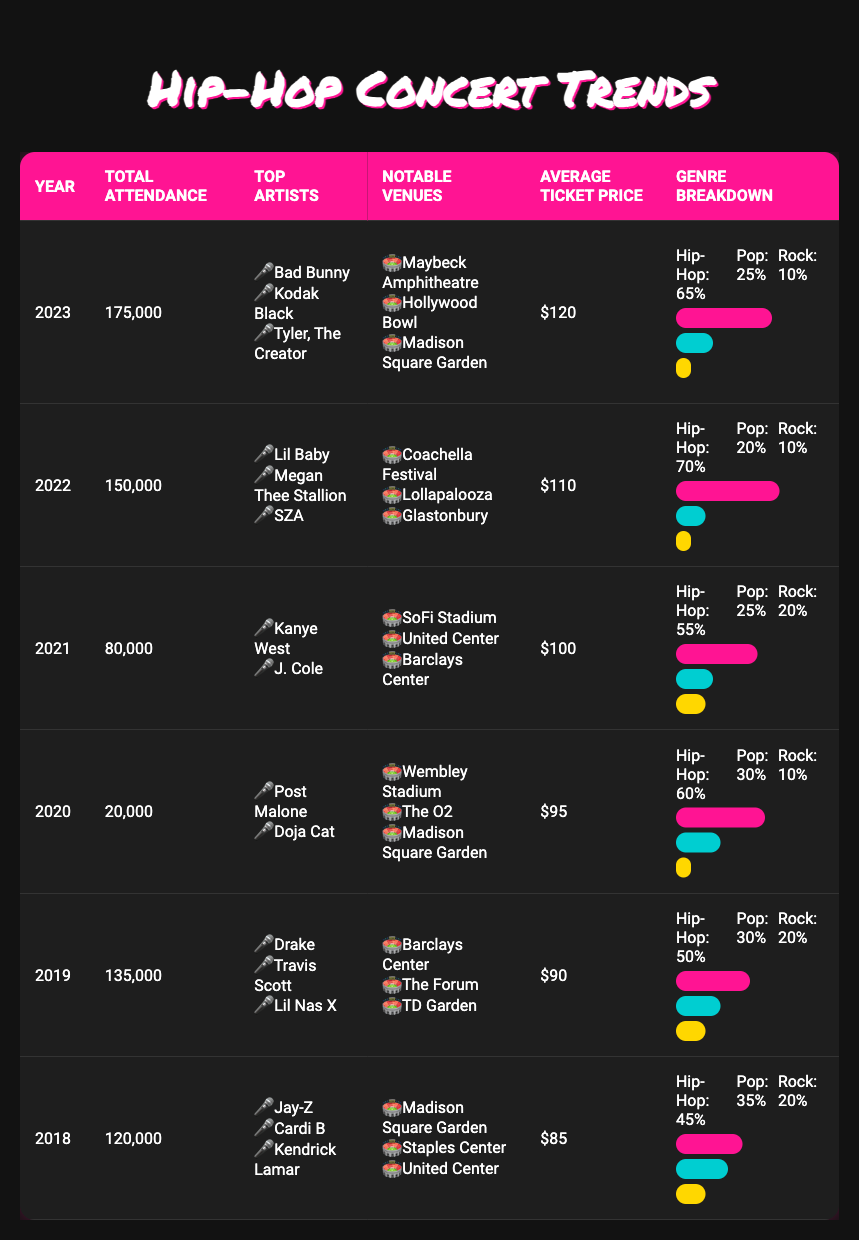What was the total attendance in 2021? By looking at the "Total Attendance" column for the year 2021, we find that the value listed is 80,000.
Answer: 80,000 Who were the top artists in 2020? The "Top Artists" column for the year 2020 lists "Post Malone" and "Doja Cat."
Answer: Post Malone, Doja Cat What was the average ticket price in 2023 and how does it compare to 2019? The average ticket price in 2023 is $120, and in 2019, it was $90. The difference is $120 - $90 = $30.
Answer: $30 Is hip-hop the most popular genre in 2022? In 2022, the genre breakdown shows hip-hop at 70%, which is higher than pop at 20% and rock at 10%. Thus, hip-hop is the most popular genre.
Answer: Yes Which year had the highest total attendance and what were the top artists? The highest total attendance is in 2023 with 175,000 attendees. The top artists for that year are "Bad Bunny," "Kodak Black," and "Tyler, The Creator."
Answer: 2023, Bad Bunny, Kodak Black, Tyler, The Creator What was the total attendance for hip-hop concerts from 2018 to 2022? We sum the total attendance for hip-hop concerts across the years 2018 (120,000), 2019 (135,000), 2020 (20,000), 2021 (80,000), and 2022 (150,000), which results in 120,000 + 135,000 + 20,000 + 80,000 + 150,000 = 505,000.
Answer: 505,000 Did the average ticket price increase from 2018 to 2023? The average ticket price in 2018 was $85 and in 2023 it was $120. The increase is calculated as $120 - $85 = $35. Therefore, it did increase.
Answer: Yes Which year had the least number of top artists listed? The years 2020 and 2021 both have only two top artists listed.
Answer: 2020 and 2021 How much has the total attendance changed from 2018 to 2023? The total attendance in 2018 was 120,000 and in 2023 it was 175,000. The change is calculated as 175,000 - 120,000 = 55,000.
Answer: 55,000 What percentage of total attendance was hip-hop in 2019? The total attendance in 2019 was 135,000 and hip-hop accounted for 50%. Calculating this gives 135,000 * 0.50 = 67,500.
Answer: 67,500 